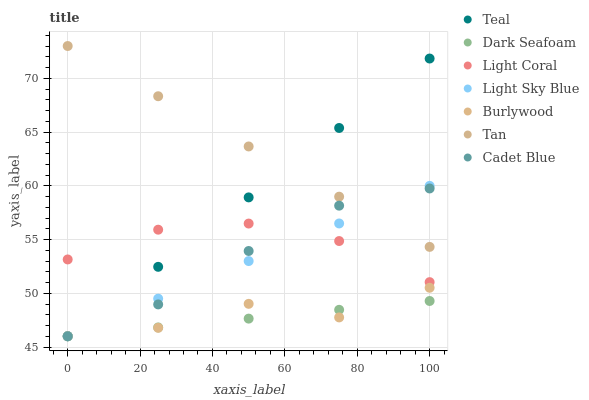Does Dark Seafoam have the minimum area under the curve?
Answer yes or no. Yes. Does Tan have the maximum area under the curve?
Answer yes or no. Yes. Does Burlywood have the minimum area under the curve?
Answer yes or no. No. Does Burlywood have the maximum area under the curve?
Answer yes or no. No. Is Dark Seafoam the smoothest?
Answer yes or no. Yes. Is Burlywood the roughest?
Answer yes or no. Yes. Is Light Coral the smoothest?
Answer yes or no. No. Is Light Coral the roughest?
Answer yes or no. No. Does Cadet Blue have the lowest value?
Answer yes or no. Yes. Does Light Coral have the lowest value?
Answer yes or no. No. Does Tan have the highest value?
Answer yes or no. Yes. Does Burlywood have the highest value?
Answer yes or no. No. Is Light Coral less than Tan?
Answer yes or no. Yes. Is Light Coral greater than Dark Seafoam?
Answer yes or no. Yes. Does Light Sky Blue intersect Tan?
Answer yes or no. Yes. Is Light Sky Blue less than Tan?
Answer yes or no. No. Is Light Sky Blue greater than Tan?
Answer yes or no. No. Does Light Coral intersect Tan?
Answer yes or no. No. 